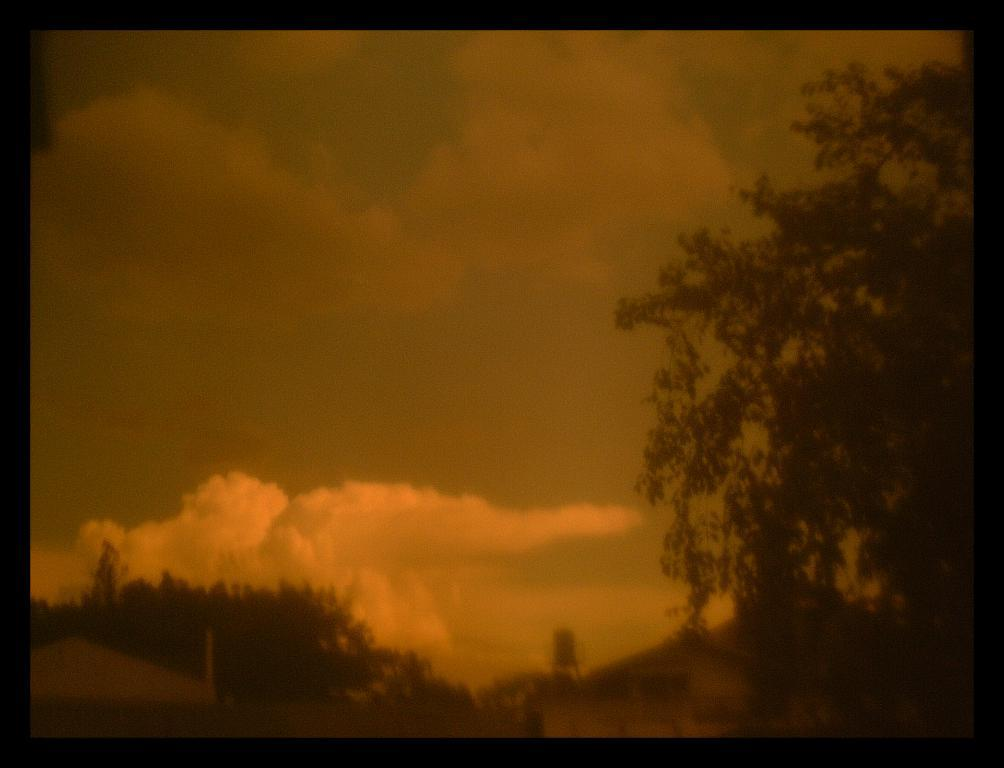What type of structures can be seen in the image? There are houses in the image. What other natural elements are present in the image? There are trees in the image. What object can be seen standing upright in the image? There is a pole in the image. What is visible in the background of the image? The sky is visible in the background of the image. What can be observed in the sky? Clouds are present in the sky. How are the edges of the image defined? The image has black color borders. What type of wax is used for the houses in the image? There is no mention of wax being used for the houses in the image. What religion is practiced by the trees in the image? Trees do not practice any religion, as they are inanimate objects. 